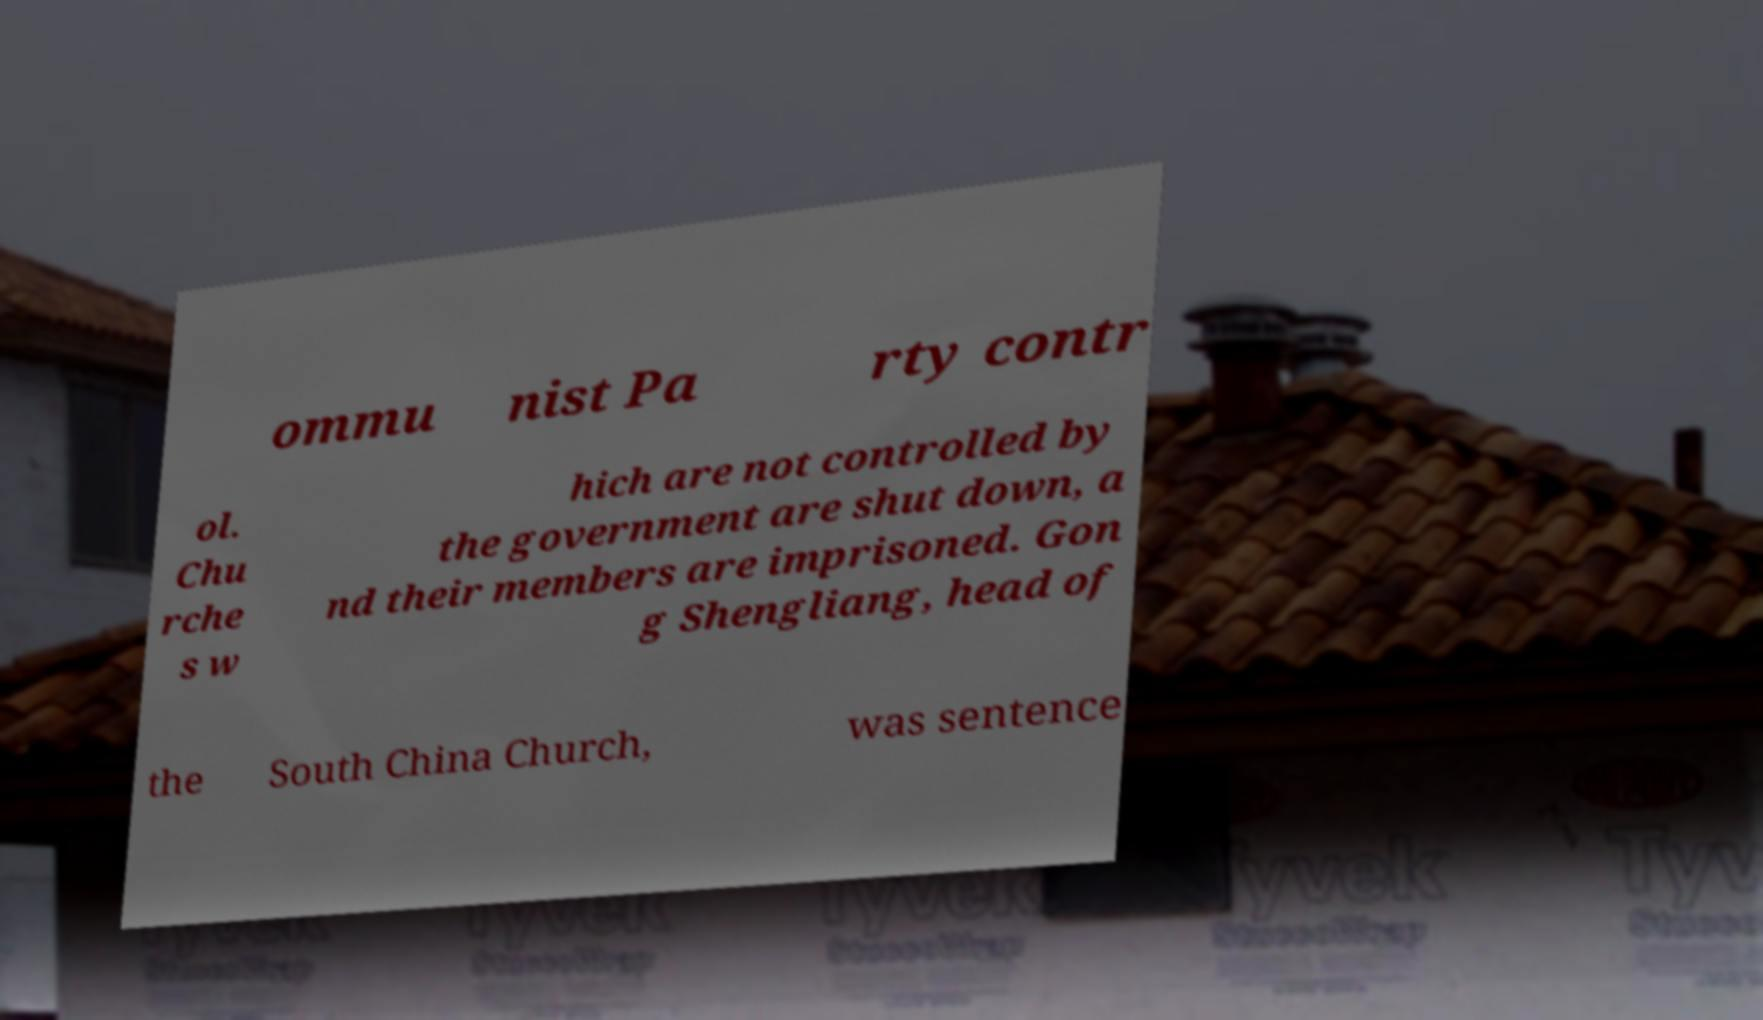Could you assist in decoding the text presented in this image and type it out clearly? ommu nist Pa rty contr ol. Chu rche s w hich are not controlled by the government are shut down, a nd their members are imprisoned. Gon g Shengliang, head of the South China Church, was sentence 